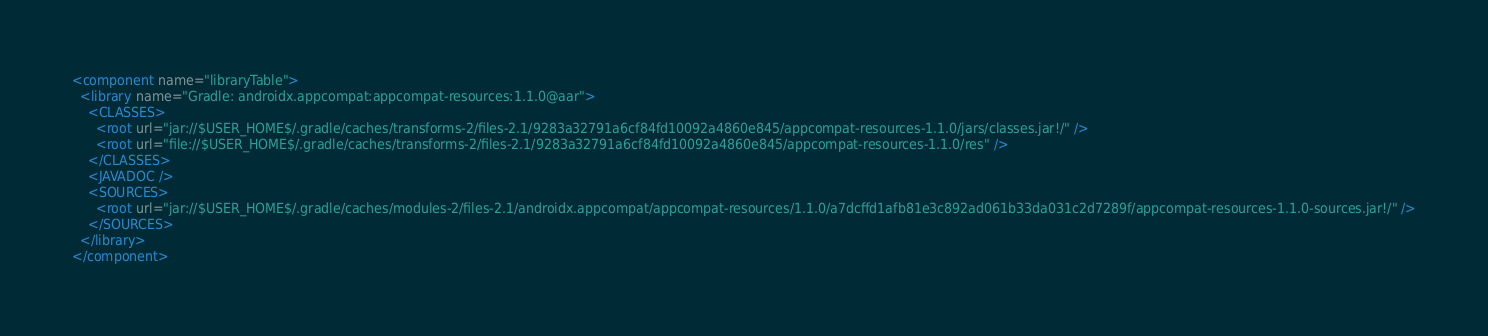Convert code to text. <code><loc_0><loc_0><loc_500><loc_500><_XML_><component name="libraryTable">
  <library name="Gradle: androidx.appcompat:appcompat-resources:1.1.0@aar">
    <CLASSES>
      <root url="jar://$USER_HOME$/.gradle/caches/transforms-2/files-2.1/9283a32791a6cf84fd10092a4860e845/appcompat-resources-1.1.0/jars/classes.jar!/" />
      <root url="file://$USER_HOME$/.gradle/caches/transforms-2/files-2.1/9283a32791a6cf84fd10092a4860e845/appcompat-resources-1.1.0/res" />
    </CLASSES>
    <JAVADOC />
    <SOURCES>
      <root url="jar://$USER_HOME$/.gradle/caches/modules-2/files-2.1/androidx.appcompat/appcompat-resources/1.1.0/a7dcffd1afb81e3c892ad061b33da031c2d7289f/appcompat-resources-1.1.0-sources.jar!/" />
    </SOURCES>
  </library>
</component></code> 